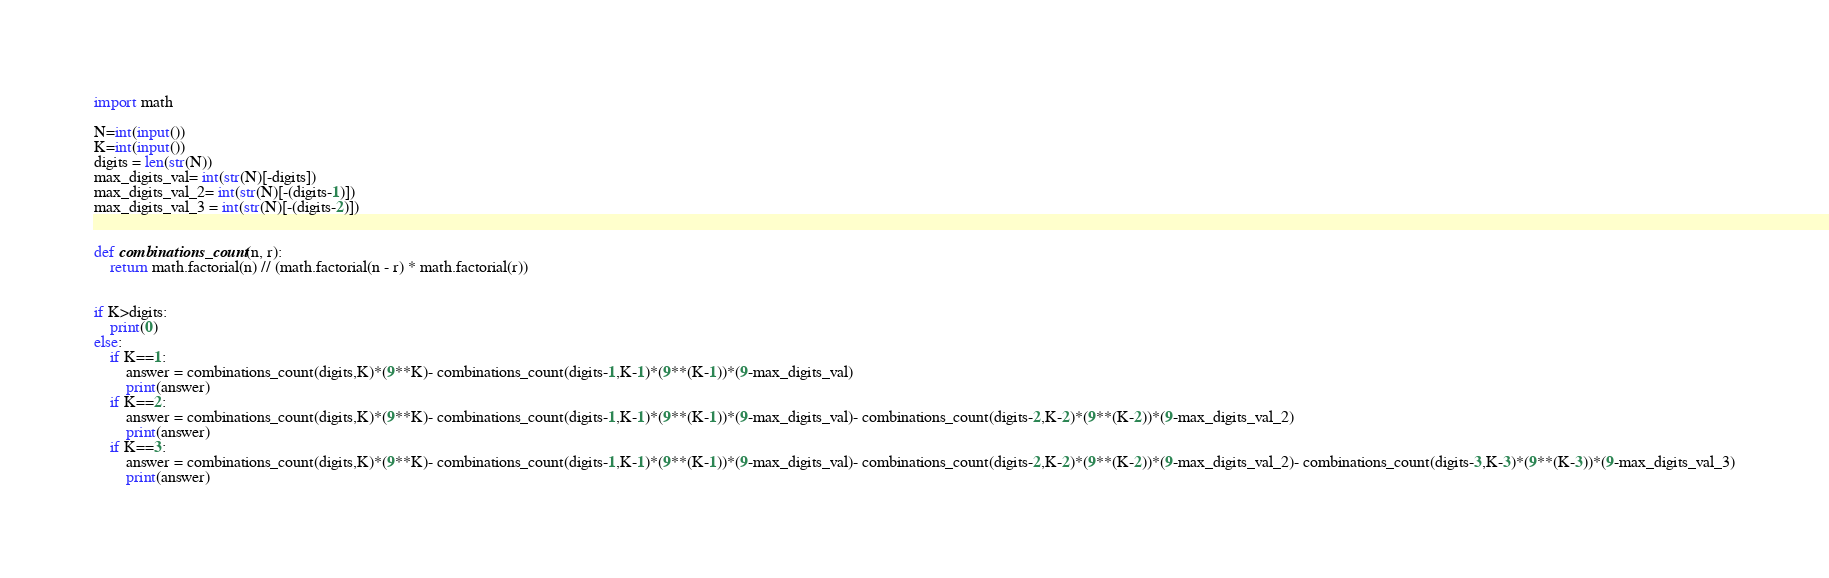Convert code to text. <code><loc_0><loc_0><loc_500><loc_500><_Python_>import math

N=int(input())
K=int(input())
digits = len(str(N))
max_digits_val= int(str(N)[-digits])
max_digits_val_2= int(str(N)[-(digits-1)])
max_digits_val_3 = int(str(N)[-(digits-2)])


def combinations_count(n, r):
    return math.factorial(n) // (math.factorial(n - r) * math.factorial(r))


if K>digits:
    print(0)
else:
    if K==1:
        answer = combinations_count(digits,K)*(9**K)- combinations_count(digits-1,K-1)*(9**(K-1))*(9-max_digits_val)
        print(answer)
    if K==2:
        answer = combinations_count(digits,K)*(9**K)- combinations_count(digits-1,K-1)*(9**(K-1))*(9-max_digits_val)- combinations_count(digits-2,K-2)*(9**(K-2))*(9-max_digits_val_2)
        print(answer)
    if K==3:
        answer = combinations_count(digits,K)*(9**K)- combinations_count(digits-1,K-1)*(9**(K-1))*(9-max_digits_val)- combinations_count(digits-2,K-2)*(9**(K-2))*(9-max_digits_val_2)- combinations_count(digits-3,K-3)*(9**(K-3))*(9-max_digits_val_3)
        print(answer)
</code> 